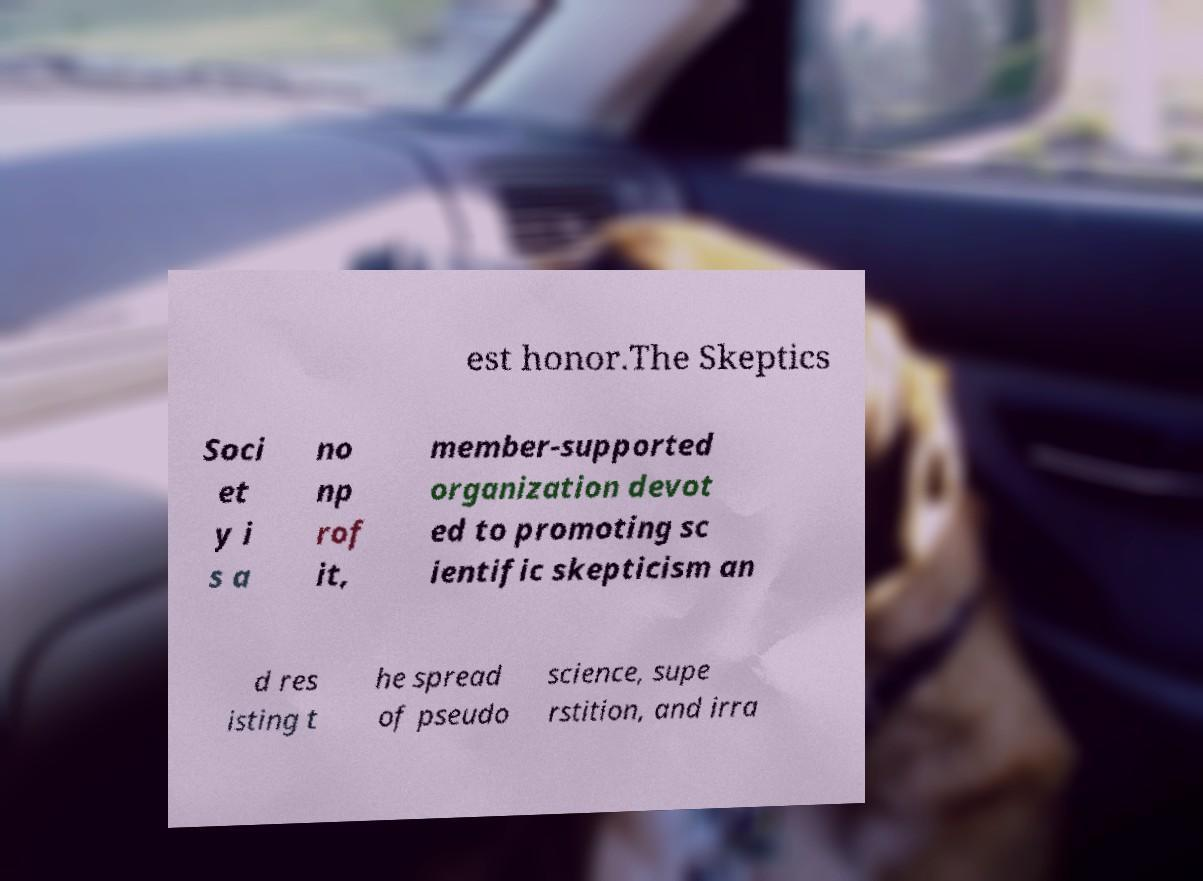Please identify and transcribe the text found in this image. est honor.The Skeptics Soci et y i s a no np rof it, member-supported organization devot ed to promoting sc ientific skepticism an d res isting t he spread of pseudo science, supe rstition, and irra 